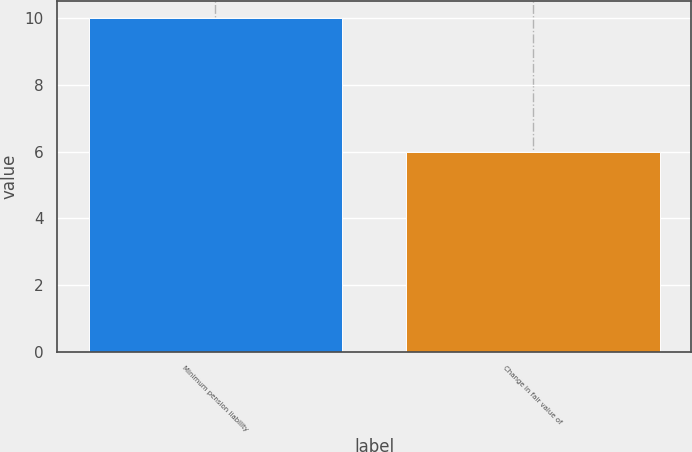Convert chart to OTSL. <chart><loc_0><loc_0><loc_500><loc_500><bar_chart><fcel>Minimum pension liability<fcel>Change in fair value of<nl><fcel>10<fcel>6<nl></chart> 